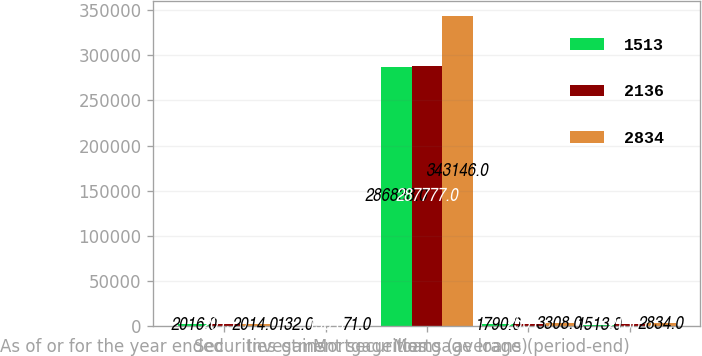Convert chart to OTSL. <chart><loc_0><loc_0><loc_500><loc_500><stacked_bar_chart><ecel><fcel>As of or for the year ended<fcel>Securities gains<fcel>Investment securities<fcel>Mortgage loans (average)<fcel>Mortgage loans (period-end)<nl><fcel>1513<fcel>2016<fcel>132<fcel>286838<fcel>1790<fcel>1513<nl><fcel>2136<fcel>2015<fcel>190<fcel>287777<fcel>2501<fcel>2136<nl><fcel>2834<fcel>2014<fcel>71<fcel>343146<fcel>3308<fcel>2834<nl></chart> 